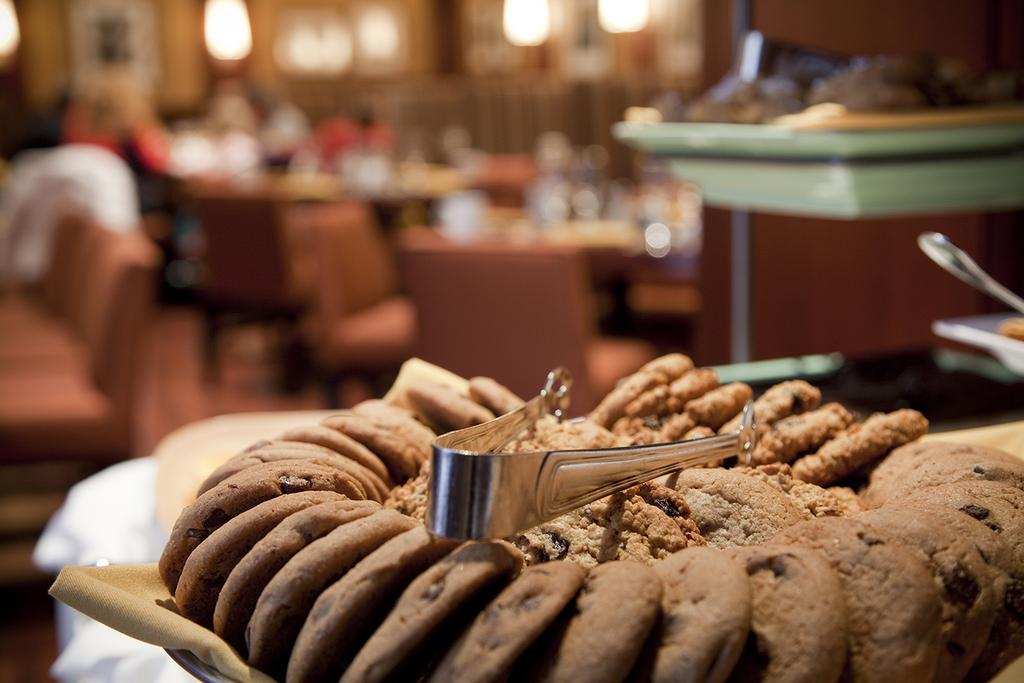What type of food is on the plate in the image? There are biscuits on a plate in the image. What is the purpose of the holder on the plate? The holder on the plate is likely for holding the biscuits upright or for serving purposes. What type of furniture is present in the image? There are tables and chairs in the image. What are the people in the image doing? The presence of biscuits and chairs suggests that the people might be having a meal or a gathering. What type of lighting is present in the image? There are lights in the image. What type of decorations are on the wall in the image? There are frames attached to the wall in the image. What type of science experiment is being conducted in the image? There is no indication of a science experiment in the image; it features biscuits on a plate with a holder, tables, chairs, people, lights, and frames on the wall. What type of birthday celebration is depicted in the image? There is no indication of a birthday celebration in the image; it features biscuits on a plate with a holder, tables, chairs, people, lights, and frames on the wall. What type of yak can be seen in the image? There is no yak present in the image; it features biscuits on a plate with a holder, tables, chairs, people, lights, and frames on the wall. 